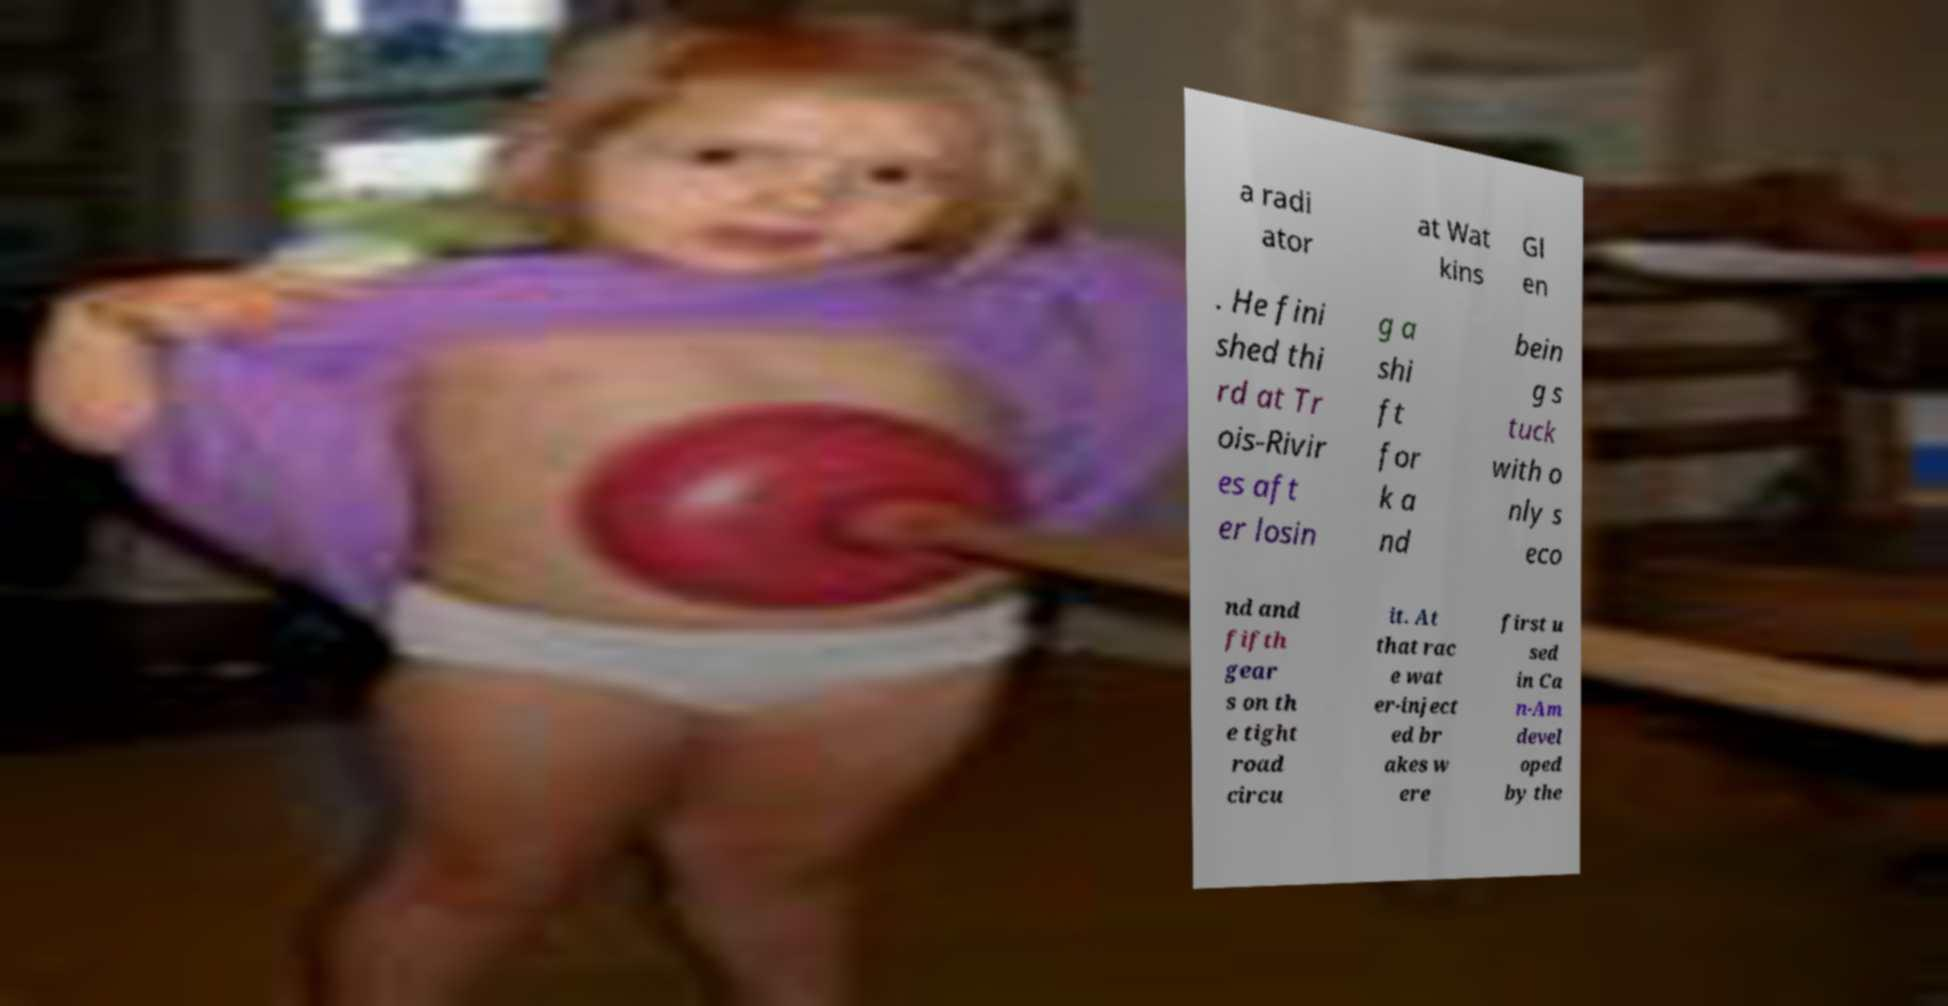Please read and relay the text visible in this image. What does it say? a radi ator at Wat kins Gl en . He fini shed thi rd at Tr ois-Rivir es aft er losin g a shi ft for k a nd bein g s tuck with o nly s eco nd and fifth gear s on th e tight road circu it. At that rac e wat er-inject ed br akes w ere first u sed in Ca n-Am devel oped by the 